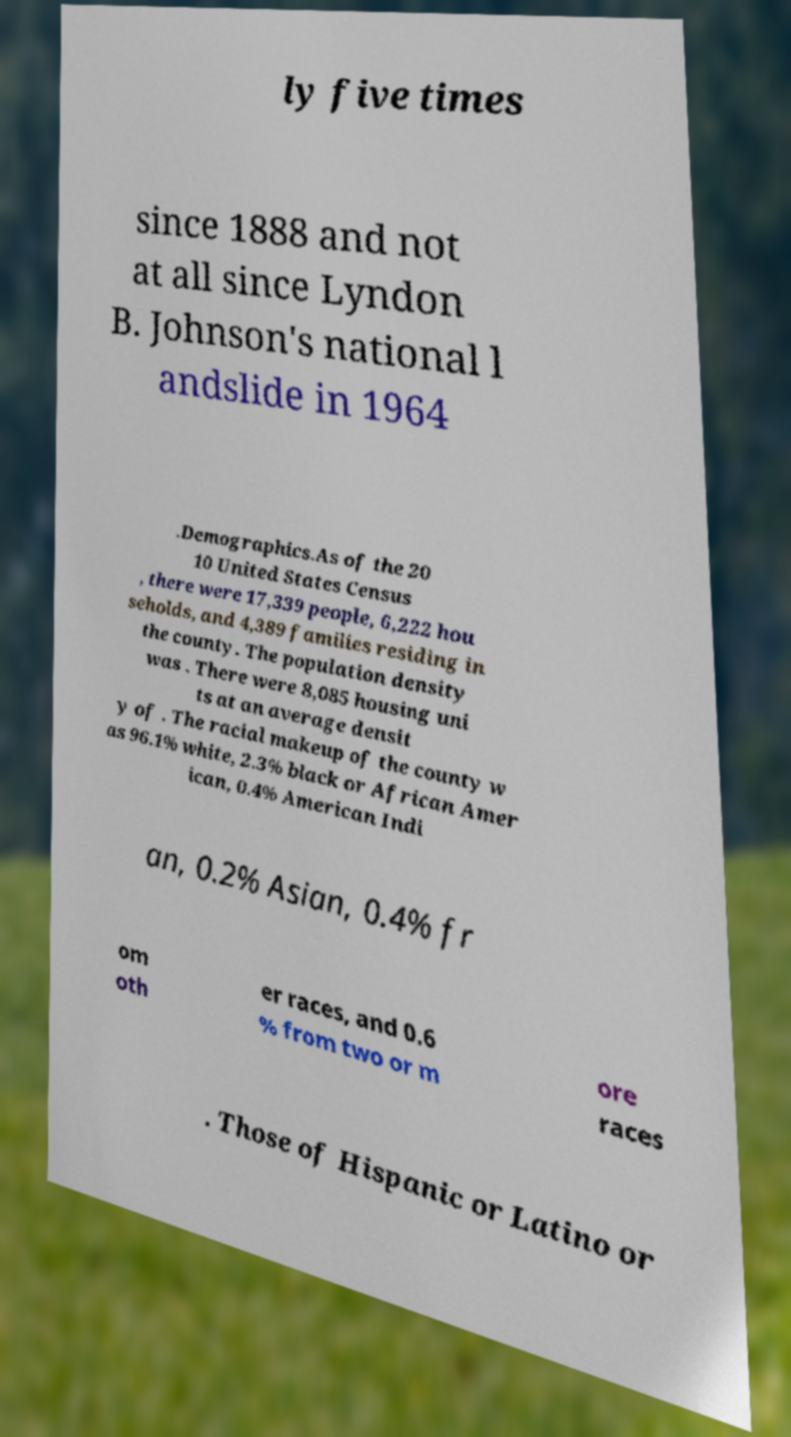Could you extract and type out the text from this image? ly five times since 1888 and not at all since Lyndon B. Johnson's national l andslide in 1964 .Demographics.As of the 20 10 United States Census , there were 17,339 people, 6,222 hou seholds, and 4,389 families residing in the county. The population density was . There were 8,085 housing uni ts at an average densit y of . The racial makeup of the county w as 96.1% white, 2.3% black or African Amer ican, 0.4% American Indi an, 0.2% Asian, 0.4% fr om oth er races, and 0.6 % from two or m ore races . Those of Hispanic or Latino or 